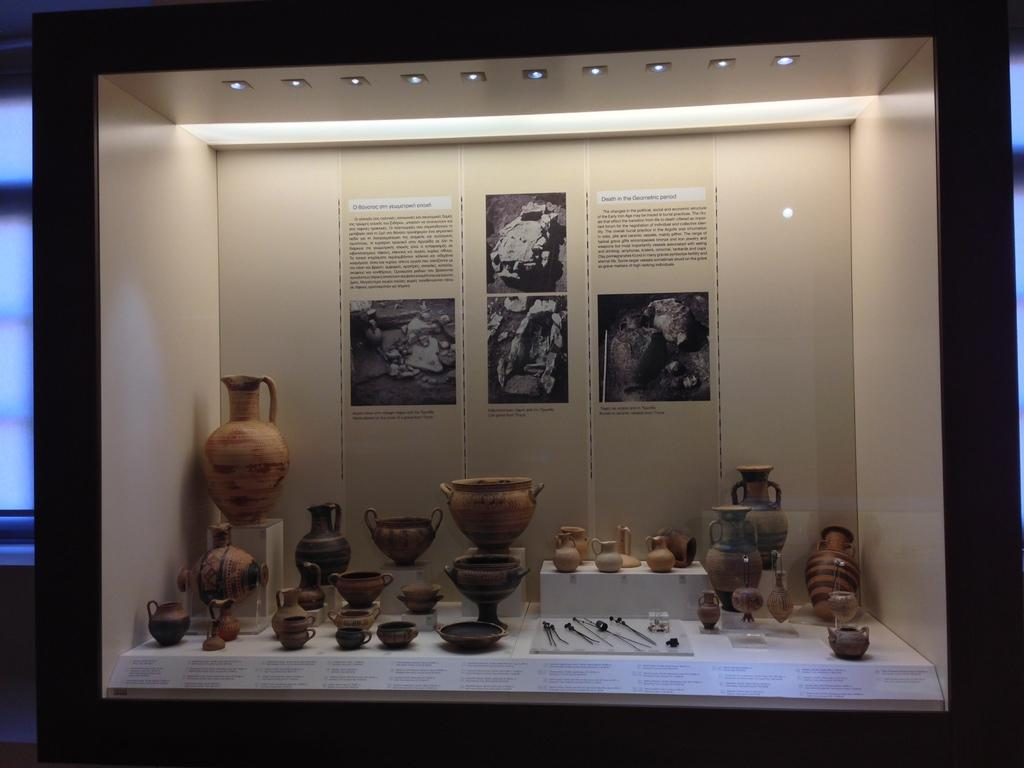What types of containers are visible in the image? There are jars, cups, and bowls in the image. Are there any other objects present in the image besides containers? Yes, there are other unspecified objects in the image. What can be seen on the wall in the background of the image? There are papers on the wall in the background of the image. What can provide illumination in the image? There are lights visible in the image. What color is the silver kitten playing with the button in the image? There is no silver kitten or button present in the image. 